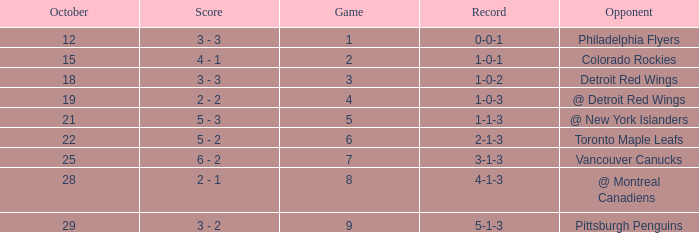Name the score for game more than 6 and before october 28 6 - 2. 